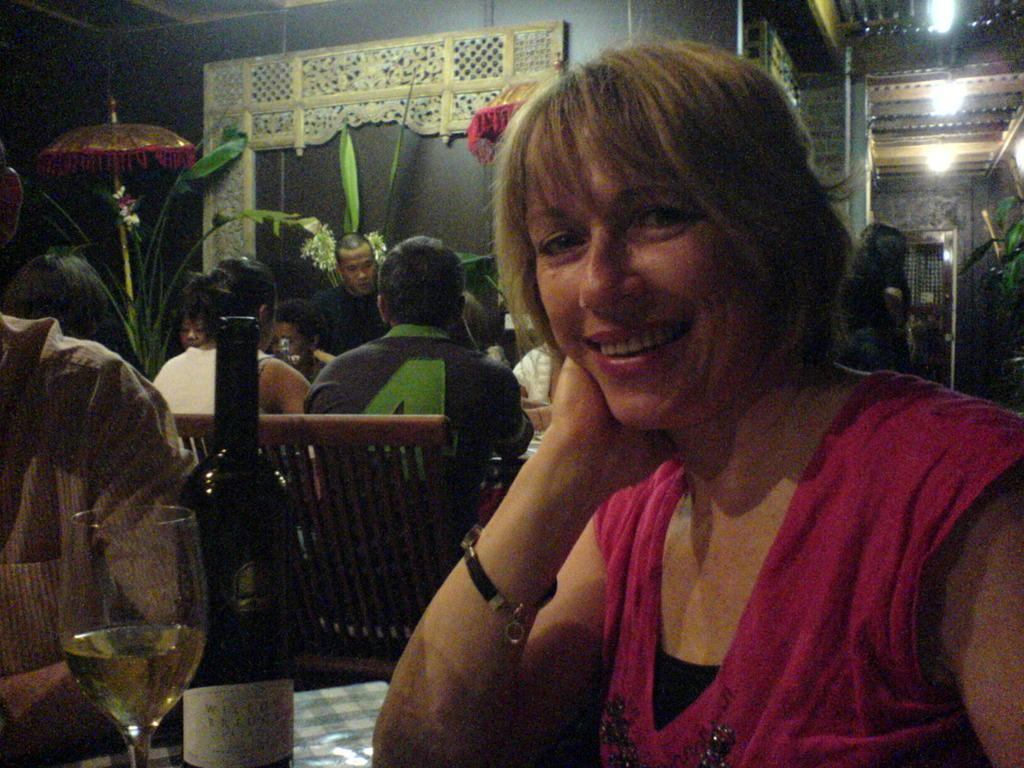What are the people in the image doing? There is a group of people sitting in the image. What type of furniture is present in the image? There are benches and tables in the image. What items can be seen on the table? There is a bottle and a glass on the table. What can be seen in the background of the image? There is a wall, an umbrella, and a plant in the background of the image. What is visible at the top of the image? There are lights visible at the top of the image. Can you see any waves in the image? There are no waves present in the image. Is there a whip visible on the table? There is no whip present on the table or in the image. 